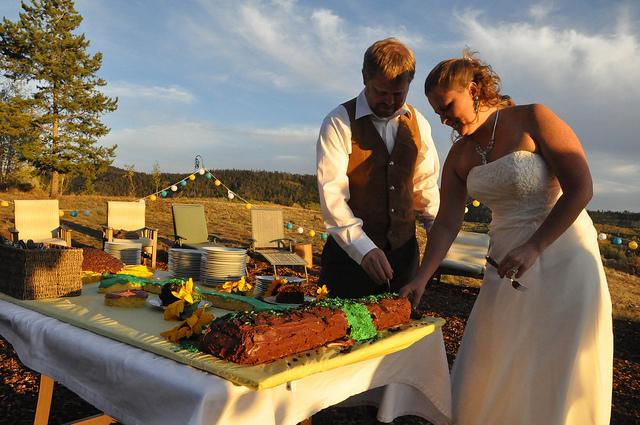Does it look like this lady should be eating pizza?
Give a very brief answer. No. Would someone who hates vegetables be excited about this selection?
Concise answer only. Yes. Which hand holds a fork?
Give a very brief answer. Left. What utensil is the woman holding?
Give a very brief answer. Fork. What flavor is the cake?
Be succinct. Chocolate. How many people?
Short answer required. 2. What kind of food is on the table?
Concise answer only. Cake. What is the man cutting?
Quick response, please. Cake. 